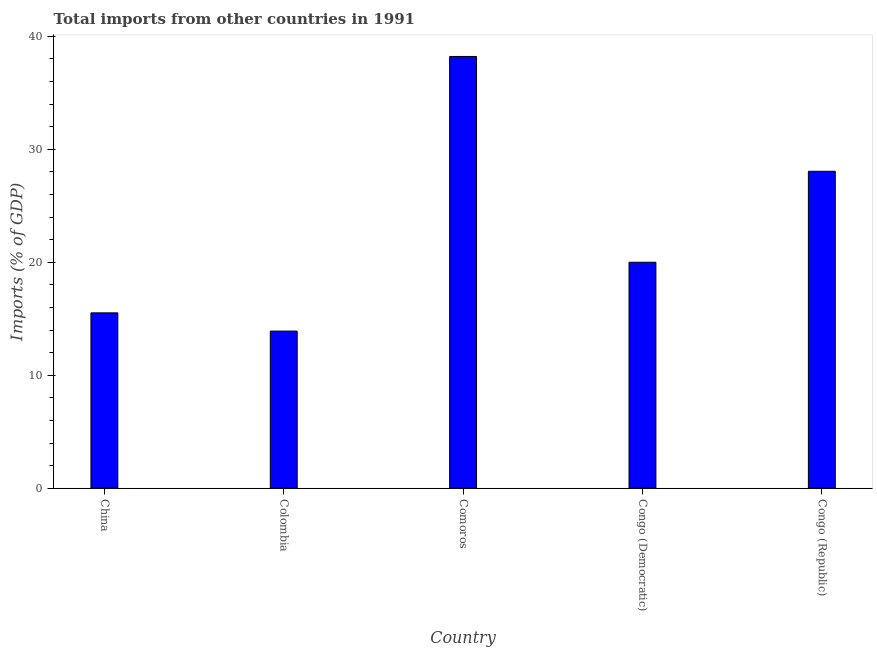Does the graph contain grids?
Give a very brief answer. No. What is the title of the graph?
Provide a short and direct response. Total imports from other countries in 1991. What is the label or title of the X-axis?
Make the answer very short. Country. What is the label or title of the Y-axis?
Keep it short and to the point. Imports (% of GDP). Across all countries, what is the maximum total imports?
Provide a short and direct response. 38.21. Across all countries, what is the minimum total imports?
Ensure brevity in your answer.  13.91. In which country was the total imports maximum?
Your answer should be compact. Comoros. In which country was the total imports minimum?
Offer a terse response. Colombia. What is the sum of the total imports?
Provide a succinct answer. 115.69. What is the difference between the total imports in China and Colombia?
Your answer should be very brief. 1.61. What is the average total imports per country?
Your answer should be compact. 23.14. What is the median total imports?
Your answer should be compact. 20. In how many countries, is the total imports greater than 38 %?
Provide a short and direct response. 1. What is the ratio of the total imports in Comoros to that in Congo (Democratic)?
Ensure brevity in your answer.  1.91. Is the difference between the total imports in Comoros and Congo (Republic) greater than the difference between any two countries?
Keep it short and to the point. No. What is the difference between the highest and the second highest total imports?
Keep it short and to the point. 10.16. Is the sum of the total imports in Congo (Democratic) and Congo (Republic) greater than the maximum total imports across all countries?
Provide a succinct answer. Yes. What is the difference between the highest and the lowest total imports?
Provide a short and direct response. 24.3. How many bars are there?
Offer a terse response. 5. How many countries are there in the graph?
Make the answer very short. 5. What is the difference between two consecutive major ticks on the Y-axis?
Ensure brevity in your answer.  10. What is the Imports (% of GDP) in China?
Ensure brevity in your answer.  15.52. What is the Imports (% of GDP) in Colombia?
Provide a succinct answer. 13.91. What is the Imports (% of GDP) of Comoros?
Give a very brief answer. 38.21. What is the Imports (% of GDP) in Congo (Republic)?
Make the answer very short. 28.05. What is the difference between the Imports (% of GDP) in China and Colombia?
Provide a short and direct response. 1.61. What is the difference between the Imports (% of GDP) in China and Comoros?
Provide a succinct answer. -22.69. What is the difference between the Imports (% of GDP) in China and Congo (Democratic)?
Ensure brevity in your answer.  -4.48. What is the difference between the Imports (% of GDP) in China and Congo (Republic)?
Your answer should be very brief. -12.53. What is the difference between the Imports (% of GDP) in Colombia and Comoros?
Give a very brief answer. -24.3. What is the difference between the Imports (% of GDP) in Colombia and Congo (Democratic)?
Offer a terse response. -6.09. What is the difference between the Imports (% of GDP) in Colombia and Congo (Republic)?
Your answer should be compact. -14.14. What is the difference between the Imports (% of GDP) in Comoros and Congo (Democratic)?
Offer a terse response. 18.21. What is the difference between the Imports (% of GDP) in Comoros and Congo (Republic)?
Ensure brevity in your answer.  10.16. What is the difference between the Imports (% of GDP) in Congo (Democratic) and Congo (Republic)?
Keep it short and to the point. -8.05. What is the ratio of the Imports (% of GDP) in China to that in Colombia?
Offer a terse response. 1.12. What is the ratio of the Imports (% of GDP) in China to that in Comoros?
Provide a short and direct response. 0.41. What is the ratio of the Imports (% of GDP) in China to that in Congo (Democratic)?
Your answer should be very brief. 0.78. What is the ratio of the Imports (% of GDP) in China to that in Congo (Republic)?
Provide a succinct answer. 0.55. What is the ratio of the Imports (% of GDP) in Colombia to that in Comoros?
Offer a very short reply. 0.36. What is the ratio of the Imports (% of GDP) in Colombia to that in Congo (Democratic)?
Offer a terse response. 0.69. What is the ratio of the Imports (% of GDP) in Colombia to that in Congo (Republic)?
Your response must be concise. 0.5. What is the ratio of the Imports (% of GDP) in Comoros to that in Congo (Democratic)?
Provide a short and direct response. 1.91. What is the ratio of the Imports (% of GDP) in Comoros to that in Congo (Republic)?
Provide a short and direct response. 1.36. What is the ratio of the Imports (% of GDP) in Congo (Democratic) to that in Congo (Republic)?
Keep it short and to the point. 0.71. 